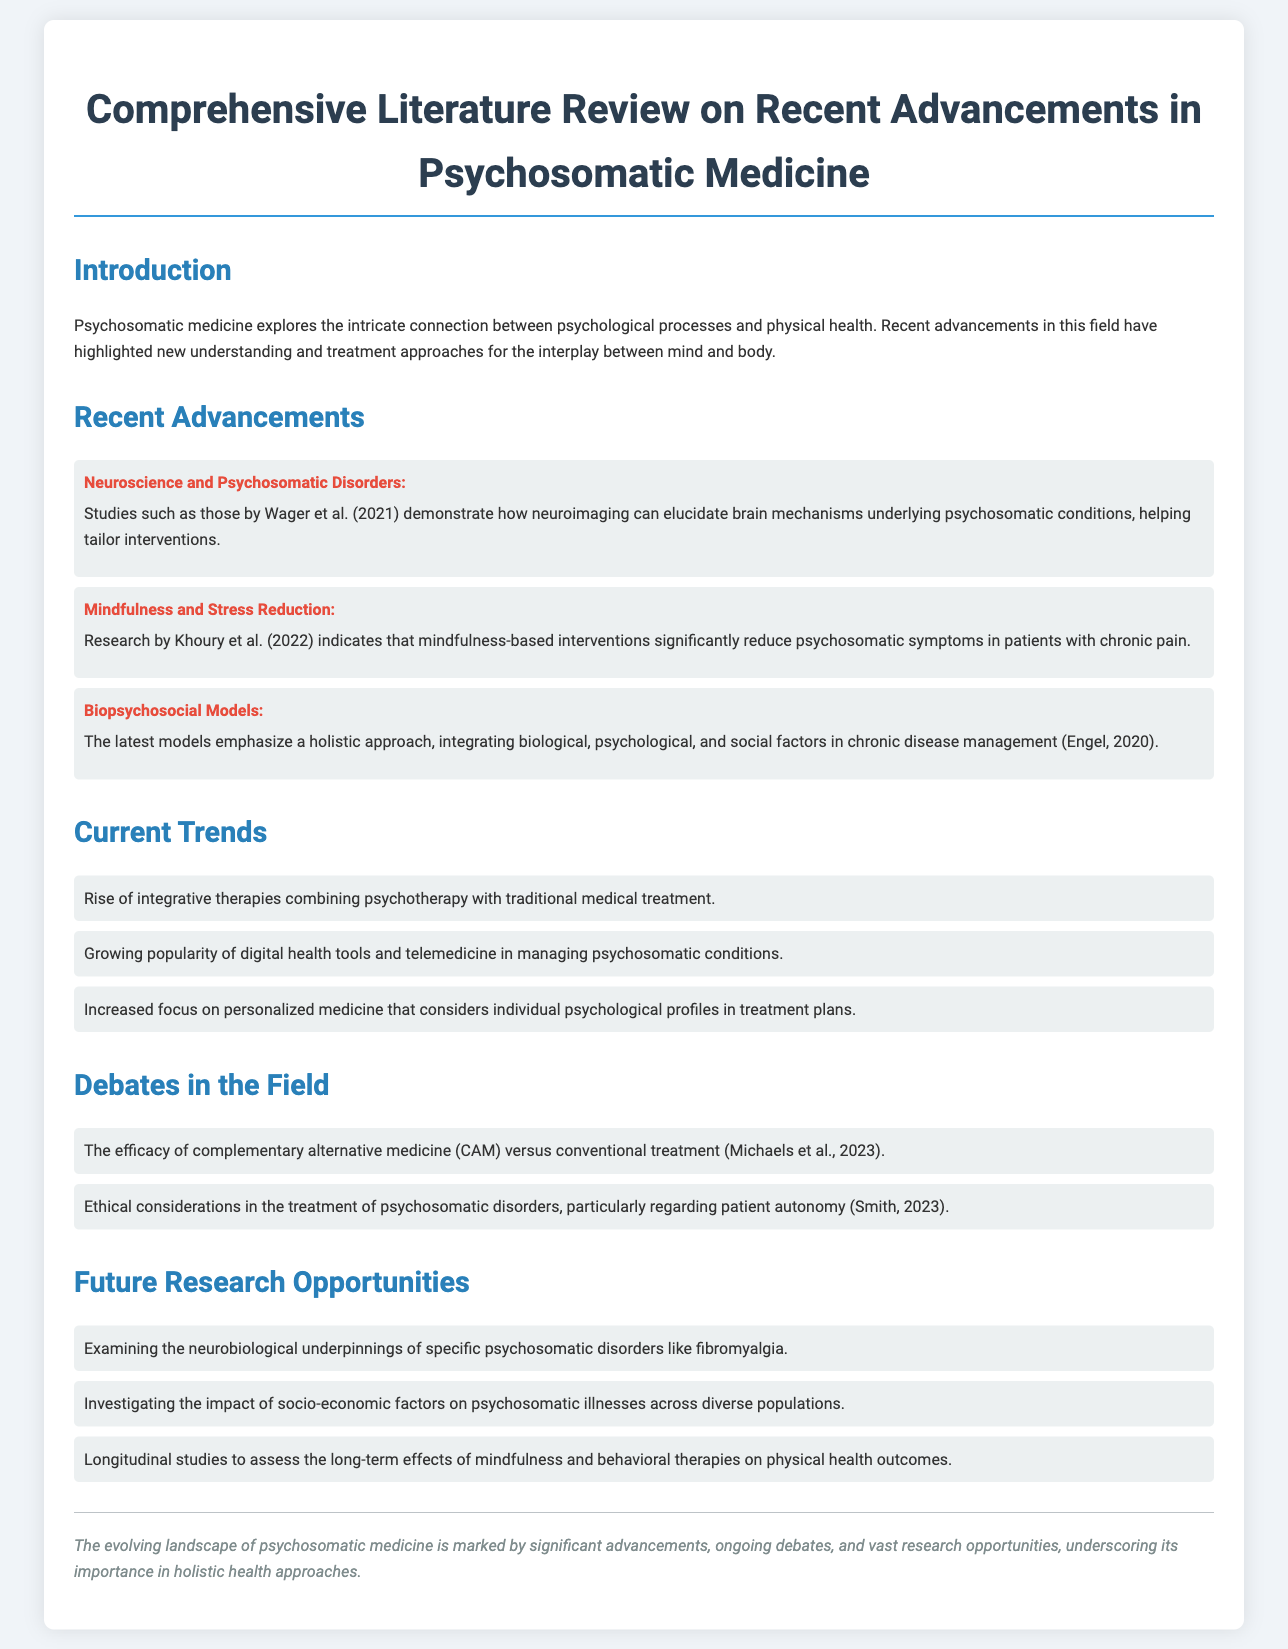What is the main focus of psychosomatic medicine? The introduction states that psychosomatic medicine explores the intricate connection between psychological processes and physical health.
Answer: connection between psychological processes and physical health Who conducted research indicating mindfulness-based interventions reduce psychosomatic symptoms? The summary under "Mindfulness and Stress Reduction" cites Khoury et al. (2022) as the researchers behind the mentioned findings.
Answer: Khoury et al. (2022) What type of models do recent advancements emphasize? Under "Biopsychosocial Models," the text discusses that the latest models emphasize a holistic approach.
Answer: holistic approach What research area is suggested for future exploration related to fibromyalgia? One of the future research opportunities mentions examining the neurobiological underpinnings of specific psychosomatic disorders like fibromyalgia.
Answer: neurobiological underpinnings Which ethical consideration is debated in the treatment of psychosomatic disorders? Under "Debates in the Field," the document mentions ethical considerations regarding patient autonomy.
Answer: patient autonomy 